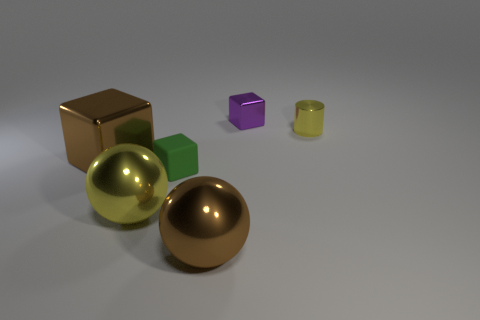Which shapes in the image have reflective surfaces? The shapes with reflective surfaces are the two spheres and the cube. The golden sphere and silver sphere have highly reflective surfaces, as does the brown cube. 